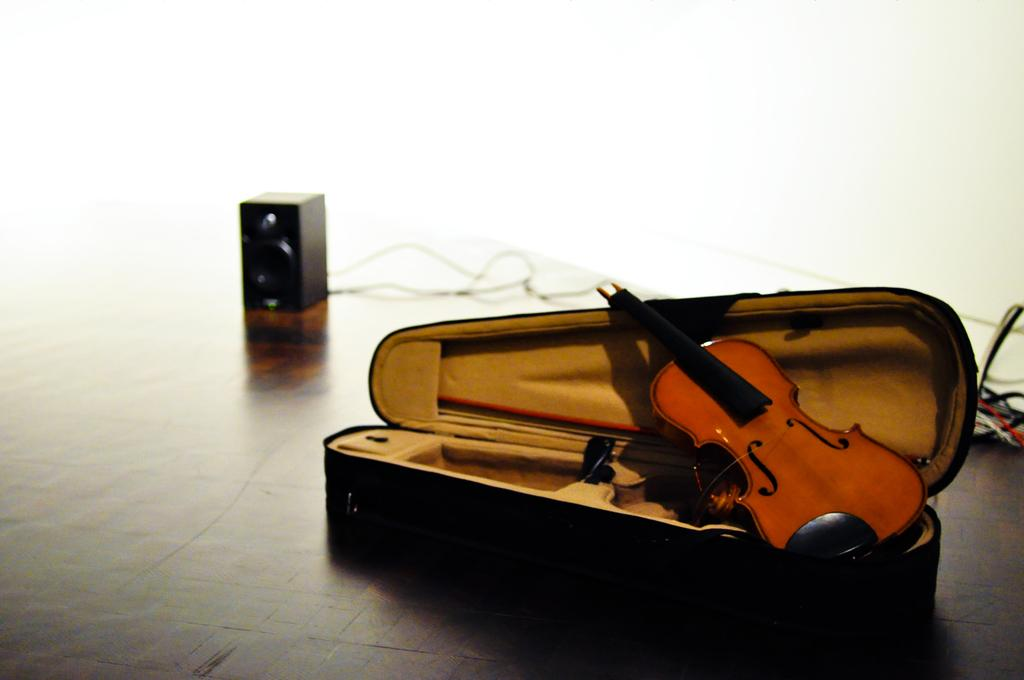What object is present in the image that is commonly used for carrying belongings? There is a suitcase in the image. What musical instrument is inside the suitcase? A violin is inside the suitcase. What part of the violin is also inside the suitcase? A violin stick is inside the suitcase. What electronic device is visible on the left side of the image? There is a speaker on the left side of the image. How are the wires of the speakers arranged in the image? The wires of the speakers are visible from left to right in the image. What type of behavior can be observed in the pocket of the suitcase? There is no pocket present in the suitcase, and therefore no behavior can be observed. 